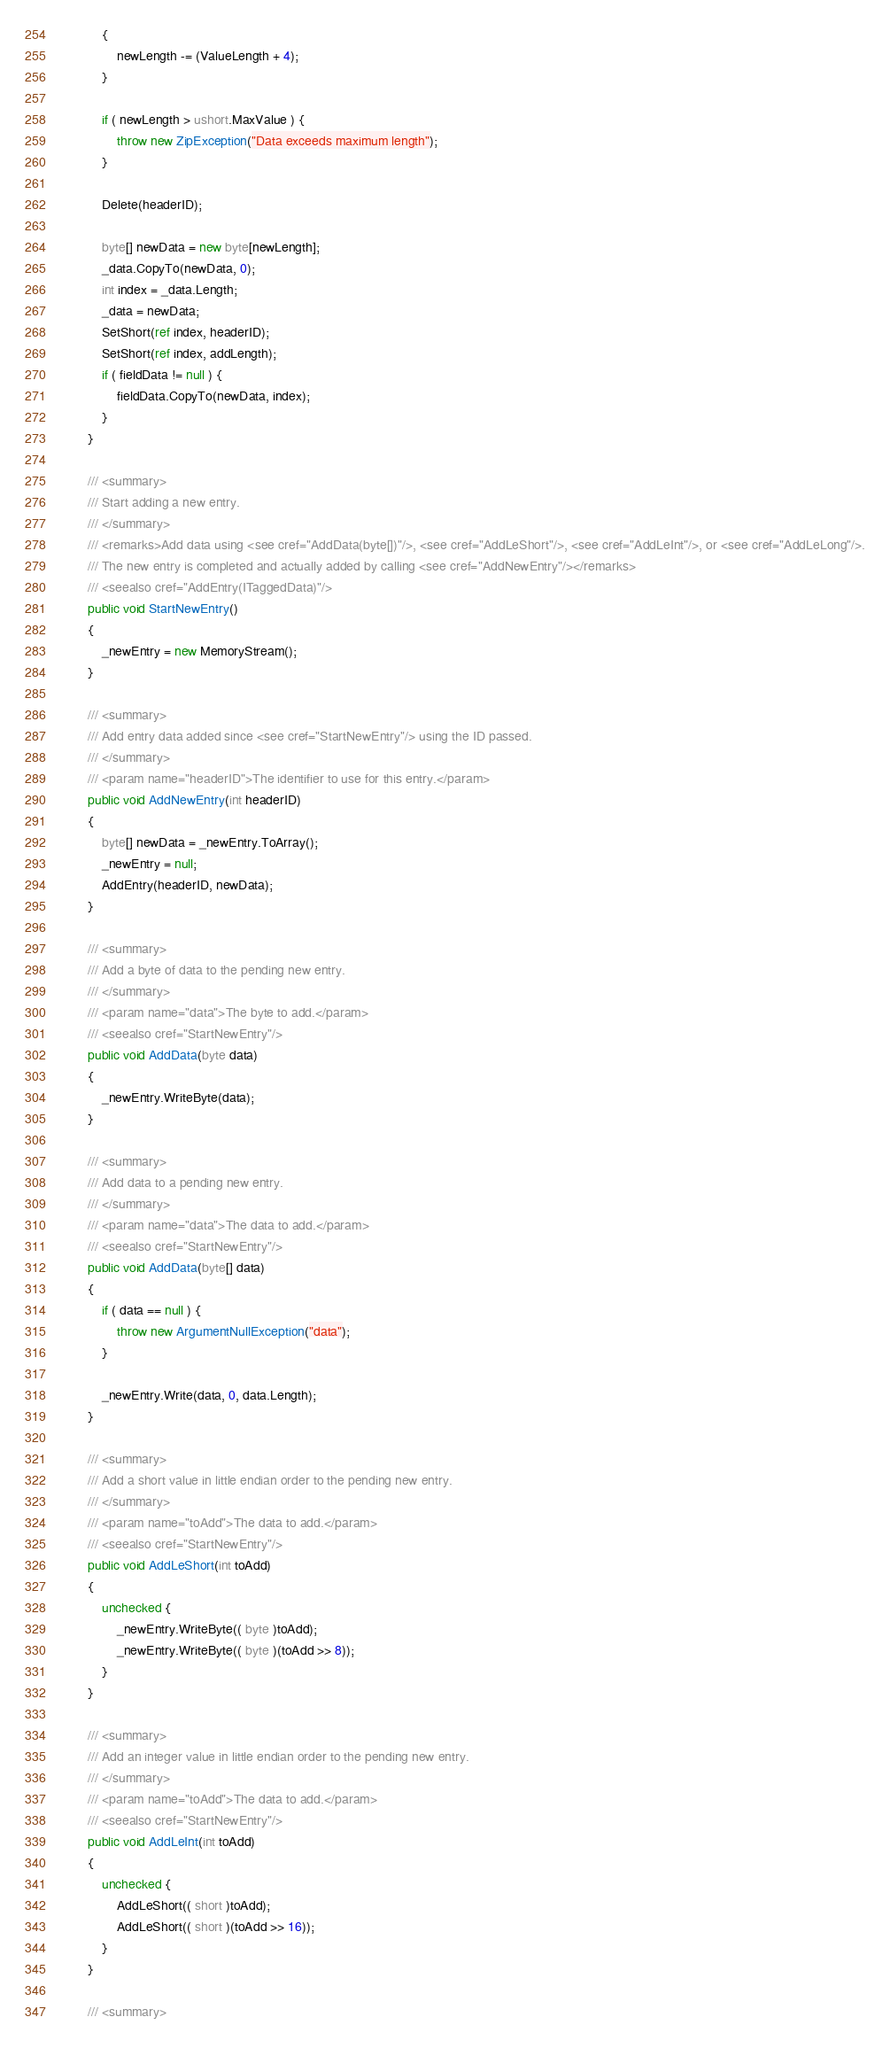<code> <loc_0><loc_0><loc_500><loc_500><_C#_>			{
				newLength -= (ValueLength + 4);
			}

			if ( newLength > ushort.MaxValue ) {
				throw new ZipException("Data exceeds maximum length");
			}
			
			Delete(headerID);

			byte[] newData = new byte[newLength];
			_data.CopyTo(newData, 0);
			int index = _data.Length;
			_data = newData;
			SetShort(ref index, headerID);
			SetShort(ref index, addLength);
			if ( fieldData != null ) {
				fieldData.CopyTo(newData, index);
			}
		}

		/// <summary>
		/// Start adding a new entry.
		/// </summary>
		/// <remarks>Add data using <see cref="AddData(byte[])"/>, <see cref="AddLeShort"/>, <see cref="AddLeInt"/>, or <see cref="AddLeLong"/>.
		/// The new entry is completed and actually added by calling <see cref="AddNewEntry"/></remarks>
		/// <seealso cref="AddEntry(ITaggedData)"/>
		public void StartNewEntry()
		{
			_newEntry = new MemoryStream();
		}

		/// <summary>
		/// Add entry data added since <see cref="StartNewEntry"/> using the ID passed.
		/// </summary>
		/// <param name="headerID">The identifier to use for this entry.</param>
		public void AddNewEntry(int headerID)
		{
			byte[] newData = _newEntry.ToArray();
			_newEntry = null;
			AddEntry(headerID, newData);
		}

		/// <summary>
		/// Add a byte of data to the pending new entry.
		/// </summary>
		/// <param name="data">The byte to add.</param>
		/// <seealso cref="StartNewEntry"/>
		public void AddData(byte data)
		{
			_newEntry.WriteByte(data);
		}

		/// <summary>
		/// Add data to a pending new entry.
		/// </summary>
		/// <param name="data">The data to add.</param>
		/// <seealso cref="StartNewEntry"/>
		public void AddData(byte[] data)
		{
			if ( data == null ) {
				throw new ArgumentNullException("data");
			}

			_newEntry.Write(data, 0, data.Length);
		}

		/// <summary>
		/// Add a short value in little endian order to the pending new entry.
		/// </summary>
		/// <param name="toAdd">The data to add.</param>
		/// <seealso cref="StartNewEntry"/>
		public void AddLeShort(int toAdd)
		{
			unchecked {
				_newEntry.WriteByte(( byte )toAdd);
				_newEntry.WriteByte(( byte )(toAdd >> 8));
			}
		}

		/// <summary>
		/// Add an integer value in little endian order to the pending new entry.
		/// </summary>
		/// <param name="toAdd">The data to add.</param>
		/// <seealso cref="StartNewEntry"/>
		public void AddLeInt(int toAdd)
		{
			unchecked {
				AddLeShort(( short )toAdd);
				AddLeShort(( short )(toAdd >> 16));
			}
		}

		/// <summary></code> 